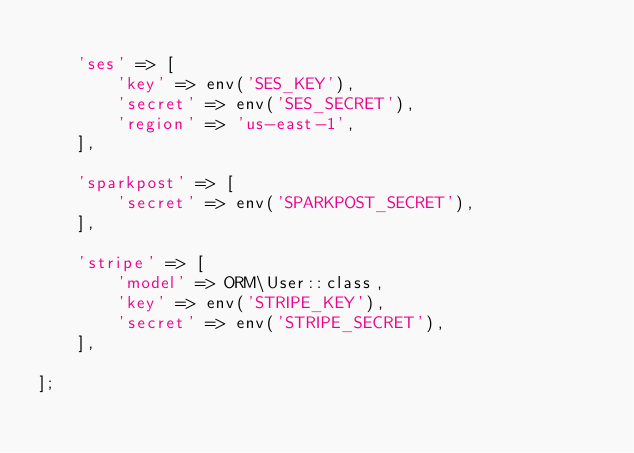Convert code to text. <code><loc_0><loc_0><loc_500><loc_500><_PHP_>
    'ses' => [
        'key' => env('SES_KEY'),
        'secret' => env('SES_SECRET'),
        'region' => 'us-east-1',
    ],

    'sparkpost' => [
        'secret' => env('SPARKPOST_SECRET'),
    ],

    'stripe' => [
        'model' => ORM\User::class,
        'key' => env('STRIPE_KEY'),
        'secret' => env('STRIPE_SECRET'),
    ],

];
</code> 